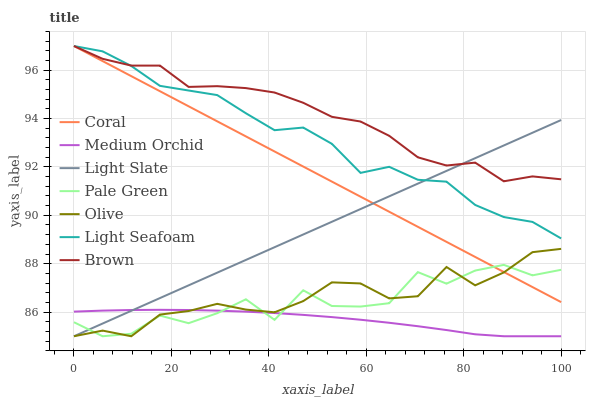Does Medium Orchid have the minimum area under the curve?
Answer yes or no. Yes. Does Brown have the maximum area under the curve?
Answer yes or no. Yes. Does Light Slate have the minimum area under the curve?
Answer yes or no. No. Does Light Slate have the maximum area under the curve?
Answer yes or no. No. Is Light Slate the smoothest?
Answer yes or no. Yes. Is Pale Green the roughest?
Answer yes or no. Yes. Is Coral the smoothest?
Answer yes or no. No. Is Coral the roughest?
Answer yes or no. No. Does Light Slate have the lowest value?
Answer yes or no. Yes. Does Coral have the lowest value?
Answer yes or no. No. Does Light Seafoam have the highest value?
Answer yes or no. Yes. Does Light Slate have the highest value?
Answer yes or no. No. Is Pale Green less than Brown?
Answer yes or no. Yes. Is Light Seafoam greater than Medium Orchid?
Answer yes or no. Yes. Does Coral intersect Brown?
Answer yes or no. Yes. Is Coral less than Brown?
Answer yes or no. No. Is Coral greater than Brown?
Answer yes or no. No. Does Pale Green intersect Brown?
Answer yes or no. No. 